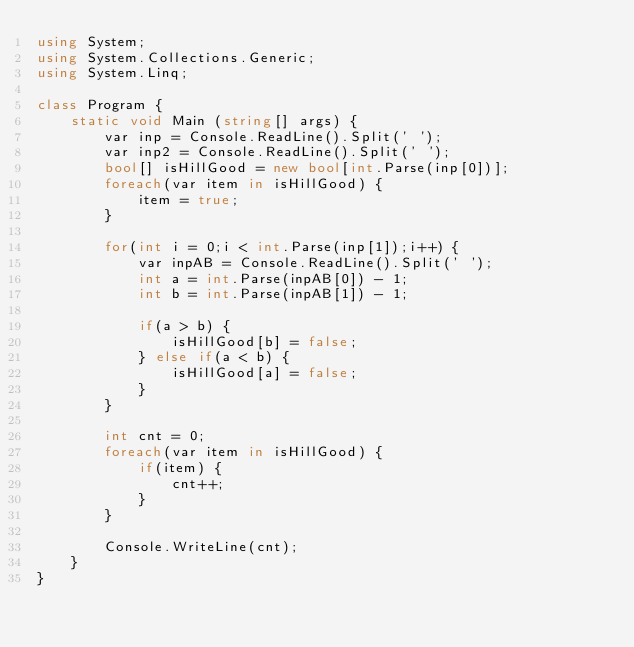Convert code to text. <code><loc_0><loc_0><loc_500><loc_500><_C#_>using System;
using System.Collections.Generic;
using System.Linq;

class Program {
    static void Main (string[] args) {
        var inp = Console.ReadLine().Split(' ');
        var inp2 = Console.ReadLine().Split(' ');
        bool[] isHillGood = new bool[int.Parse(inp[0])];
        foreach(var item in isHillGood) {
            item = true;
        }

        for(int i = 0;i < int.Parse(inp[1]);i++) {
            var inpAB = Console.ReadLine().Split(' ');
            int a = int.Parse(inpAB[0]) - 1;
            int b = int.Parse(inpAB[1]) - 1;

            if(a > b) {
                isHillGood[b] = false;
            } else if(a < b) {
                isHillGood[a] = false;
            }
        }

        int cnt = 0;
        foreach(var item in isHillGood) {
            if(item) {
                cnt++;
            }
        }

        Console.WriteLine(cnt);
    }
}</code> 